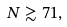Convert formula to latex. <formula><loc_0><loc_0><loc_500><loc_500>N \gtrsim 7 1 ,</formula> 